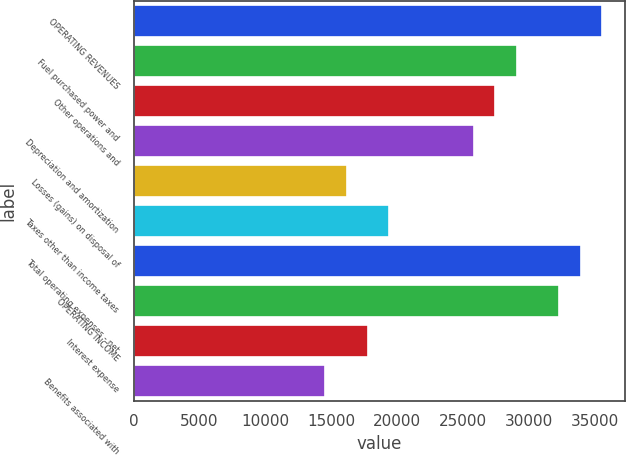Convert chart to OTSL. <chart><loc_0><loc_0><loc_500><loc_500><bar_chart><fcel>OPERATING REVENUES<fcel>Fuel purchased power and<fcel>Other operations and<fcel>Depreciation and amortization<fcel>Losses (gains) on disposal of<fcel>Taxes other than income taxes<fcel>Total operating expenses - net<fcel>OPERATING INCOME<fcel>Interest expense<fcel>Benefits associated with<nl><fcel>35533.5<fcel>29074<fcel>27459.1<fcel>25844.2<fcel>16155<fcel>19384.7<fcel>33918.6<fcel>32303.7<fcel>17769.8<fcel>14540.1<nl></chart> 